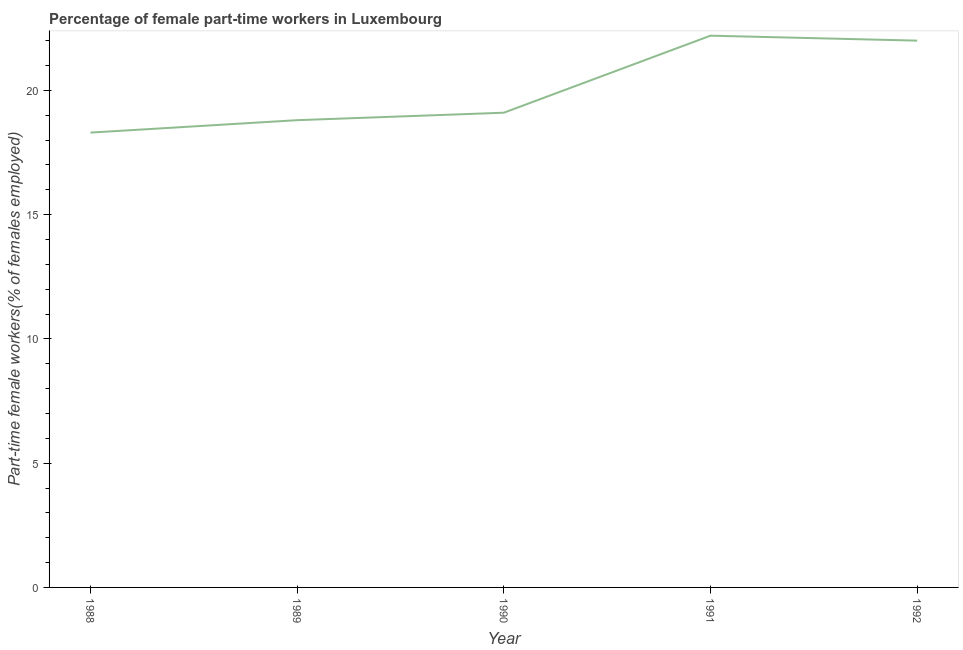What is the percentage of part-time female workers in 1991?
Provide a succinct answer. 22.2. Across all years, what is the maximum percentage of part-time female workers?
Provide a succinct answer. 22.2. Across all years, what is the minimum percentage of part-time female workers?
Give a very brief answer. 18.3. What is the sum of the percentage of part-time female workers?
Provide a short and direct response. 100.4. What is the difference between the percentage of part-time female workers in 1988 and 1992?
Give a very brief answer. -3.7. What is the average percentage of part-time female workers per year?
Your answer should be very brief. 20.08. What is the median percentage of part-time female workers?
Offer a terse response. 19.1. In how many years, is the percentage of part-time female workers greater than 18 %?
Provide a short and direct response. 5. Do a majority of the years between 1988 and 1991 (inclusive) have percentage of part-time female workers greater than 2 %?
Ensure brevity in your answer.  Yes. What is the ratio of the percentage of part-time female workers in 1988 to that in 1990?
Your answer should be very brief. 0.96. Is the difference between the percentage of part-time female workers in 1990 and 1991 greater than the difference between any two years?
Provide a succinct answer. No. What is the difference between the highest and the second highest percentage of part-time female workers?
Your response must be concise. 0.2. What is the difference between the highest and the lowest percentage of part-time female workers?
Your answer should be very brief. 3.9. Does the percentage of part-time female workers monotonically increase over the years?
Make the answer very short. No. How many years are there in the graph?
Your response must be concise. 5. Does the graph contain any zero values?
Provide a succinct answer. No. Does the graph contain grids?
Your answer should be very brief. No. What is the title of the graph?
Keep it short and to the point. Percentage of female part-time workers in Luxembourg. What is the label or title of the X-axis?
Ensure brevity in your answer.  Year. What is the label or title of the Y-axis?
Your response must be concise. Part-time female workers(% of females employed). What is the Part-time female workers(% of females employed) of 1988?
Ensure brevity in your answer.  18.3. What is the Part-time female workers(% of females employed) in 1989?
Your response must be concise. 18.8. What is the Part-time female workers(% of females employed) in 1990?
Give a very brief answer. 19.1. What is the Part-time female workers(% of females employed) of 1991?
Offer a very short reply. 22.2. What is the Part-time female workers(% of females employed) in 1992?
Provide a short and direct response. 22. What is the difference between the Part-time female workers(% of females employed) in 1988 and 1989?
Your response must be concise. -0.5. What is the difference between the Part-time female workers(% of females employed) in 1988 and 1990?
Your answer should be very brief. -0.8. What is the difference between the Part-time female workers(% of females employed) in 1988 and 1991?
Provide a succinct answer. -3.9. What is the difference between the Part-time female workers(% of females employed) in 1989 and 1990?
Make the answer very short. -0.3. What is the ratio of the Part-time female workers(% of females employed) in 1988 to that in 1989?
Keep it short and to the point. 0.97. What is the ratio of the Part-time female workers(% of females employed) in 1988 to that in 1990?
Give a very brief answer. 0.96. What is the ratio of the Part-time female workers(% of females employed) in 1988 to that in 1991?
Keep it short and to the point. 0.82. What is the ratio of the Part-time female workers(% of females employed) in 1988 to that in 1992?
Offer a terse response. 0.83. What is the ratio of the Part-time female workers(% of females employed) in 1989 to that in 1991?
Your answer should be very brief. 0.85. What is the ratio of the Part-time female workers(% of females employed) in 1989 to that in 1992?
Give a very brief answer. 0.85. What is the ratio of the Part-time female workers(% of females employed) in 1990 to that in 1991?
Your answer should be compact. 0.86. What is the ratio of the Part-time female workers(% of females employed) in 1990 to that in 1992?
Provide a short and direct response. 0.87. What is the ratio of the Part-time female workers(% of females employed) in 1991 to that in 1992?
Your response must be concise. 1.01. 